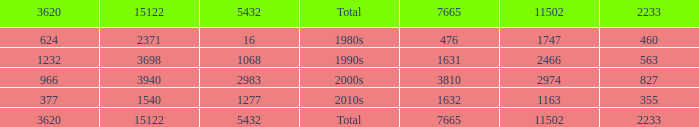What is the average 3620 value that has a 5432 of 1277 and a 15122 less than 1540? None. 